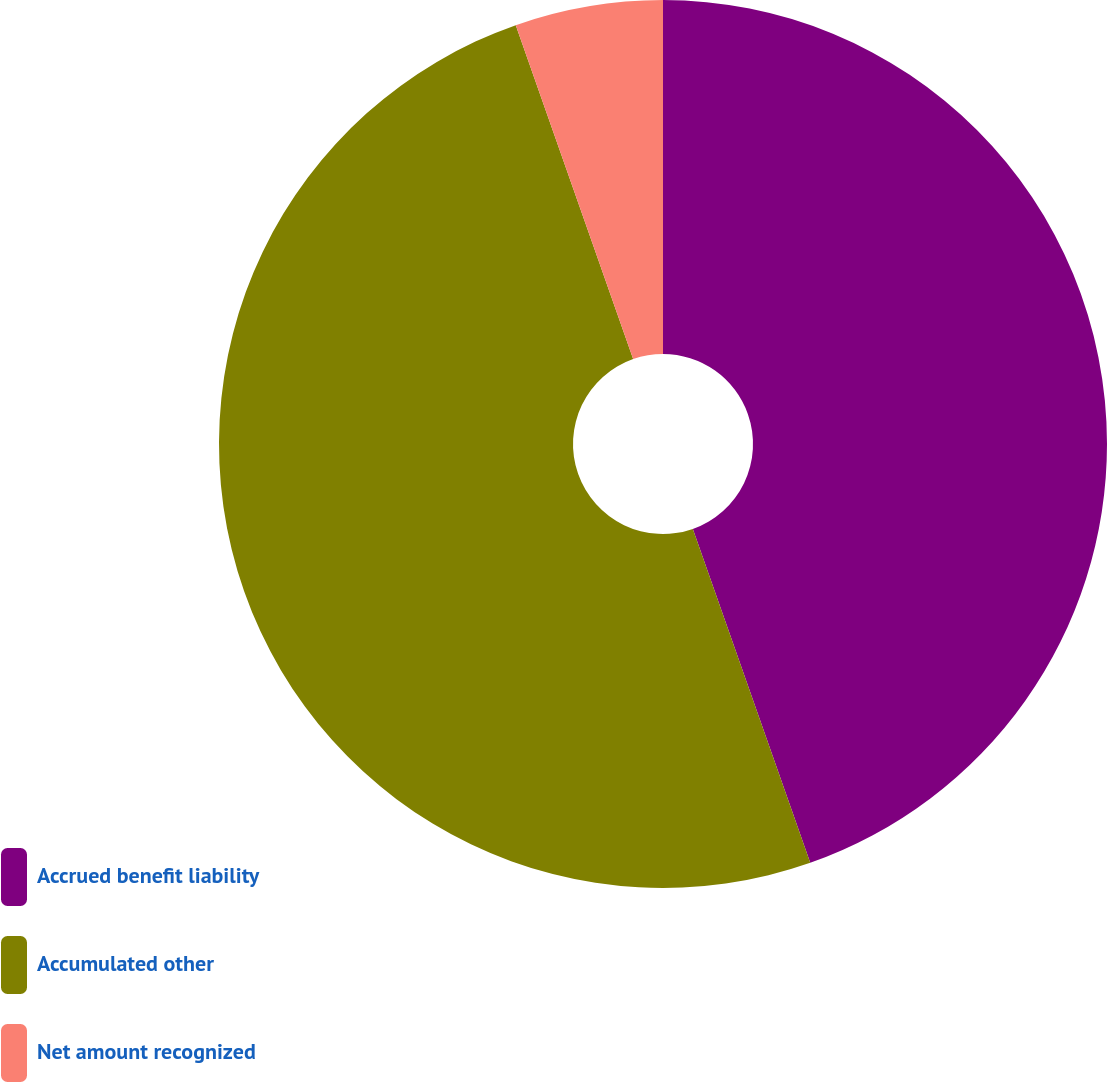<chart> <loc_0><loc_0><loc_500><loc_500><pie_chart><fcel>Accrued benefit liability<fcel>Accumulated other<fcel>Net amount recognized<nl><fcel>44.62%<fcel>50.0%<fcel>5.38%<nl></chart> 